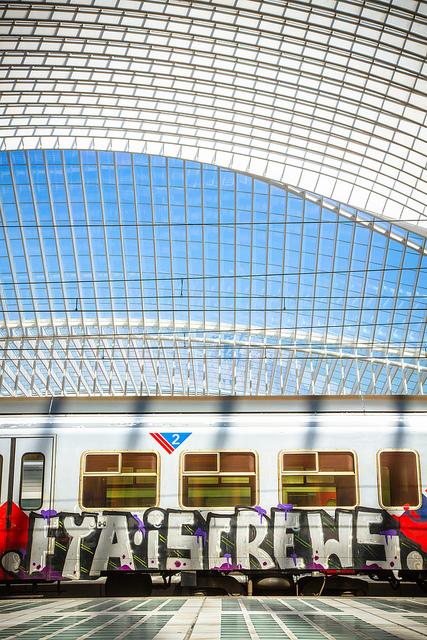What does the spray painted words say?
Quick response, please. Fya iscrews. Where is the graffiti?
Be succinct. On train. What form of transportation is shown?
Give a very brief answer. Train. 